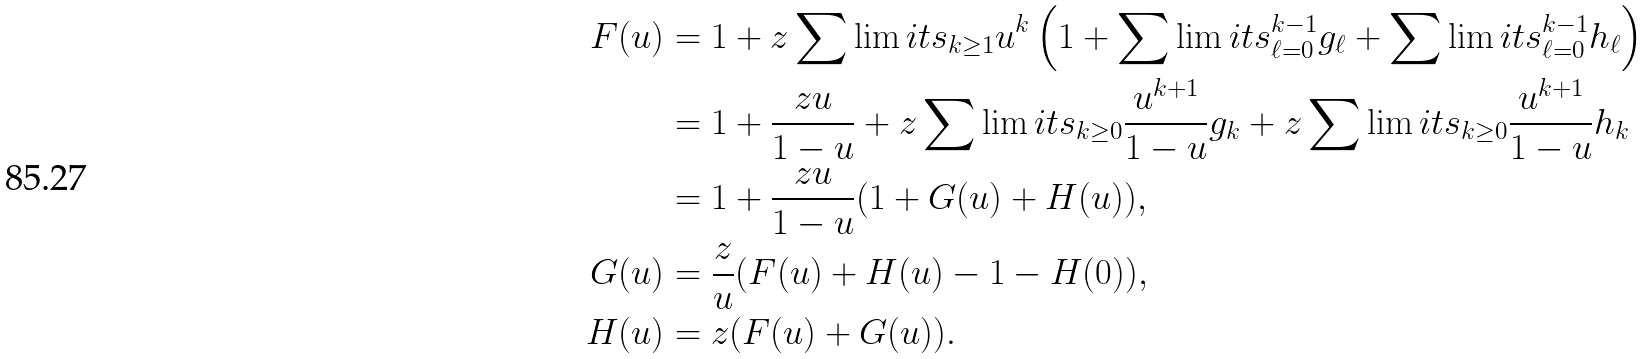<formula> <loc_0><loc_0><loc_500><loc_500>F ( u ) & = 1 + z \sum \lim i t s _ { k \geq 1 } u ^ { k } \left ( 1 + \sum \lim i t s _ { \ell = 0 } ^ { k - 1 } g _ { \ell } + \sum \lim i t s _ { \ell = 0 } ^ { k - 1 } h _ { \ell } \right ) \\ & = 1 + \frac { z u } { 1 - u } + z \sum \lim i t s _ { k \geq 0 } \frac { u ^ { k + 1 } } { 1 - u } g _ { k } + z \sum \lim i t s _ { k \geq 0 } \frac { u ^ { k + 1 } } { 1 - u } h _ { k } \\ & = 1 + \frac { z u } { 1 - u } ( 1 + G ( u ) + H ( u ) ) , \\ G ( u ) & = \frac { z } { u } ( F ( u ) + H ( u ) - 1 - H ( 0 ) ) , \\ H ( u ) & = z ( F ( u ) + G ( u ) ) .</formula> 